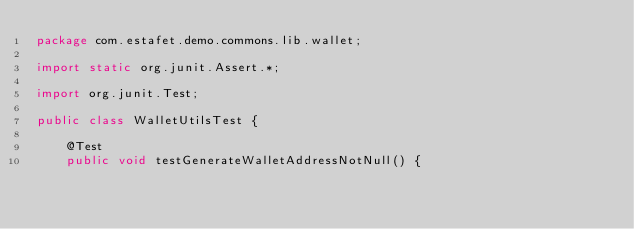<code> <loc_0><loc_0><loc_500><loc_500><_Java_>package com.estafet.demo.commons.lib.wallet;

import static org.junit.Assert.*;

import org.junit.Test;

public class WalletUtilsTest {

	@Test
	public void testGenerateWalletAddressNotNull() {</code> 